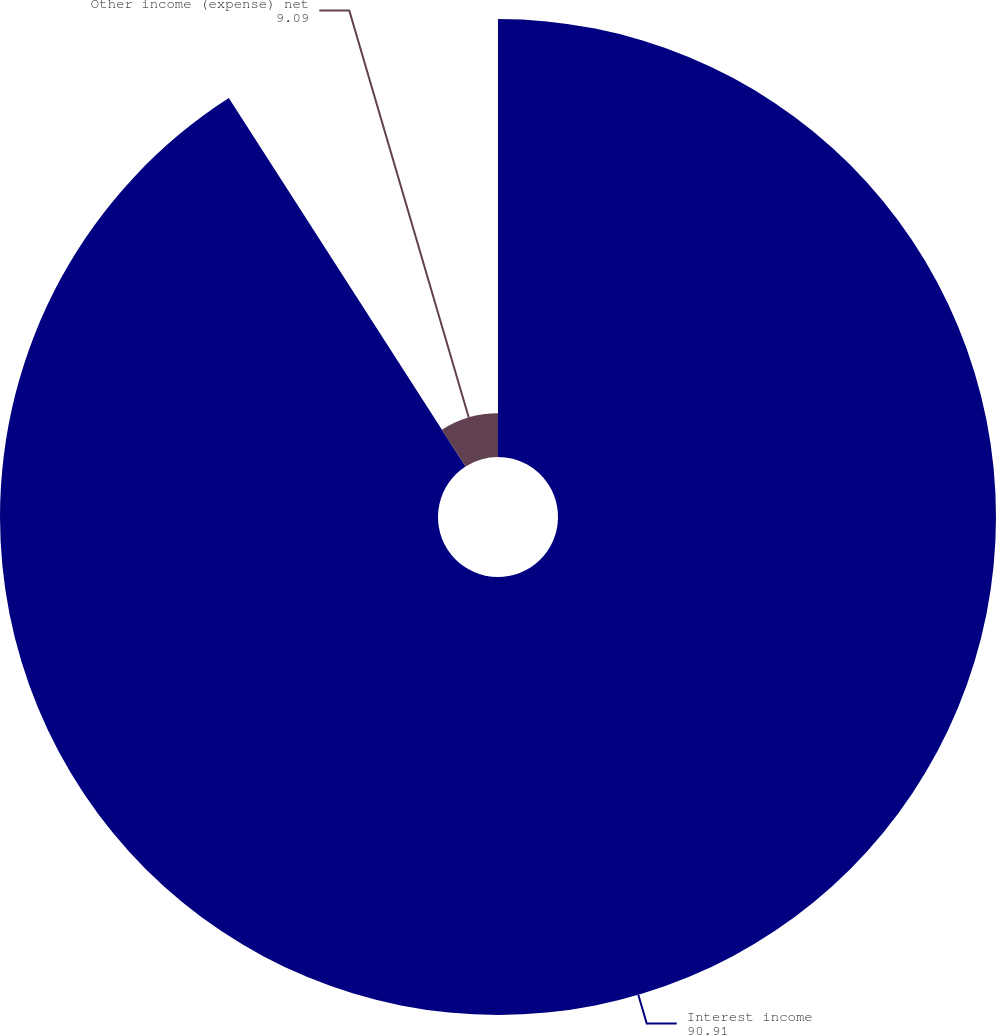<chart> <loc_0><loc_0><loc_500><loc_500><pie_chart><fcel>Interest income<fcel>Other income (expense) net<nl><fcel>90.91%<fcel>9.09%<nl></chart> 